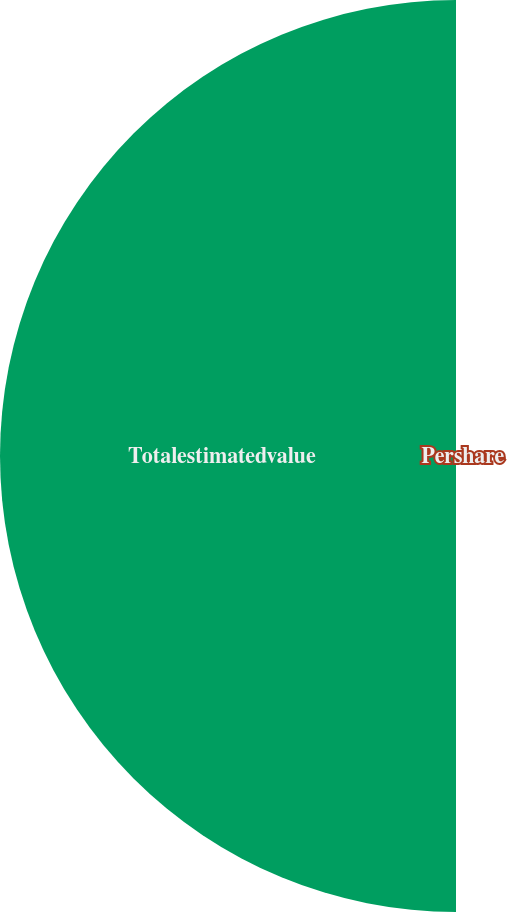Convert chart to OTSL. <chart><loc_0><loc_0><loc_500><loc_500><pie_chart><fcel>Pershare<fcel>Totalestimatedvalue<nl><fcel>0.34%<fcel>99.66%<nl></chart> 